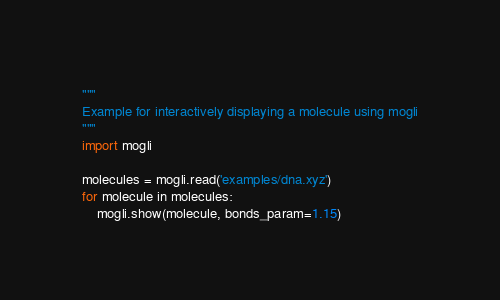<code> <loc_0><loc_0><loc_500><loc_500><_Python_>"""
Example for interactively displaying a molecule using mogli
"""
import mogli

molecules = mogli.read('examples/dna.xyz')
for molecule in molecules:
    mogli.show(molecule, bonds_param=1.15)
</code> 